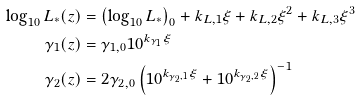Convert formula to latex. <formula><loc_0><loc_0><loc_500><loc_500>\log _ { 1 0 } L _ { * } ( z ) & = \left ( \log _ { 1 0 } L _ { * } \right ) _ { 0 } + k _ { L , 1 } \xi + k _ { L , 2 } \xi ^ { 2 } + k _ { L , 3 } \xi ^ { 3 } \\ \gamma _ { 1 } ( z ) & = \gamma _ { 1 , 0 } 1 0 ^ { k _ { \gamma _ { 1 } } \xi } \\ \gamma _ { 2 } ( z ) & = 2 \gamma _ { 2 , 0 } \left ( 1 0 ^ { k _ { \gamma _ { 2 } , 1 } \xi } + 1 0 ^ { k _ { \gamma _ { 2 } , 2 } \xi } \right ) ^ { - 1 } \\</formula> 